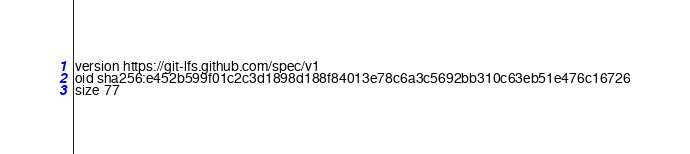Convert code to text. <code><loc_0><loc_0><loc_500><loc_500><_YAML_>version https://git-lfs.github.com/spec/v1
oid sha256:e452b599f01c2c3d1898d188f84013e78c6a3c5692bb310c63eb51e476c16726
size 77
</code> 